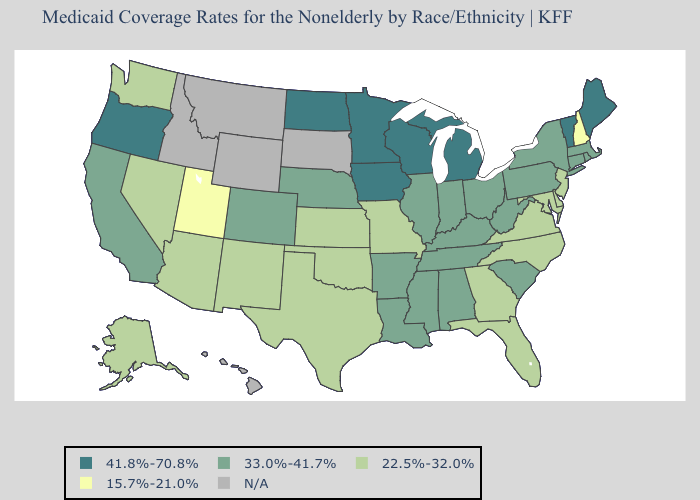What is the value of Mississippi?
Be succinct. 33.0%-41.7%. What is the highest value in the South ?
Short answer required. 33.0%-41.7%. Among the states that border Ohio , does West Virginia have the lowest value?
Answer briefly. Yes. Does West Virginia have the highest value in the USA?
Answer briefly. No. Does South Carolina have the highest value in the South?
Answer briefly. Yes. Among the states that border New Hampshire , does Massachusetts have the highest value?
Quick response, please. No. What is the value of North Carolina?
Keep it brief. 22.5%-32.0%. Name the states that have a value in the range 15.7%-21.0%?
Keep it brief. New Hampshire, Utah. Which states hav the highest value in the MidWest?
Keep it brief. Iowa, Michigan, Minnesota, North Dakota, Wisconsin. What is the value of Idaho?
Give a very brief answer. N/A. What is the value of Illinois?
Answer briefly. 33.0%-41.7%. Name the states that have a value in the range 41.8%-70.8%?
Keep it brief. Iowa, Maine, Michigan, Minnesota, North Dakota, Oregon, Vermont, Wisconsin. Among the states that border California , does Arizona have the highest value?
Write a very short answer. No. Among the states that border Oklahoma , which have the lowest value?
Be succinct. Kansas, Missouri, New Mexico, Texas. What is the value of Arkansas?
Give a very brief answer. 33.0%-41.7%. 